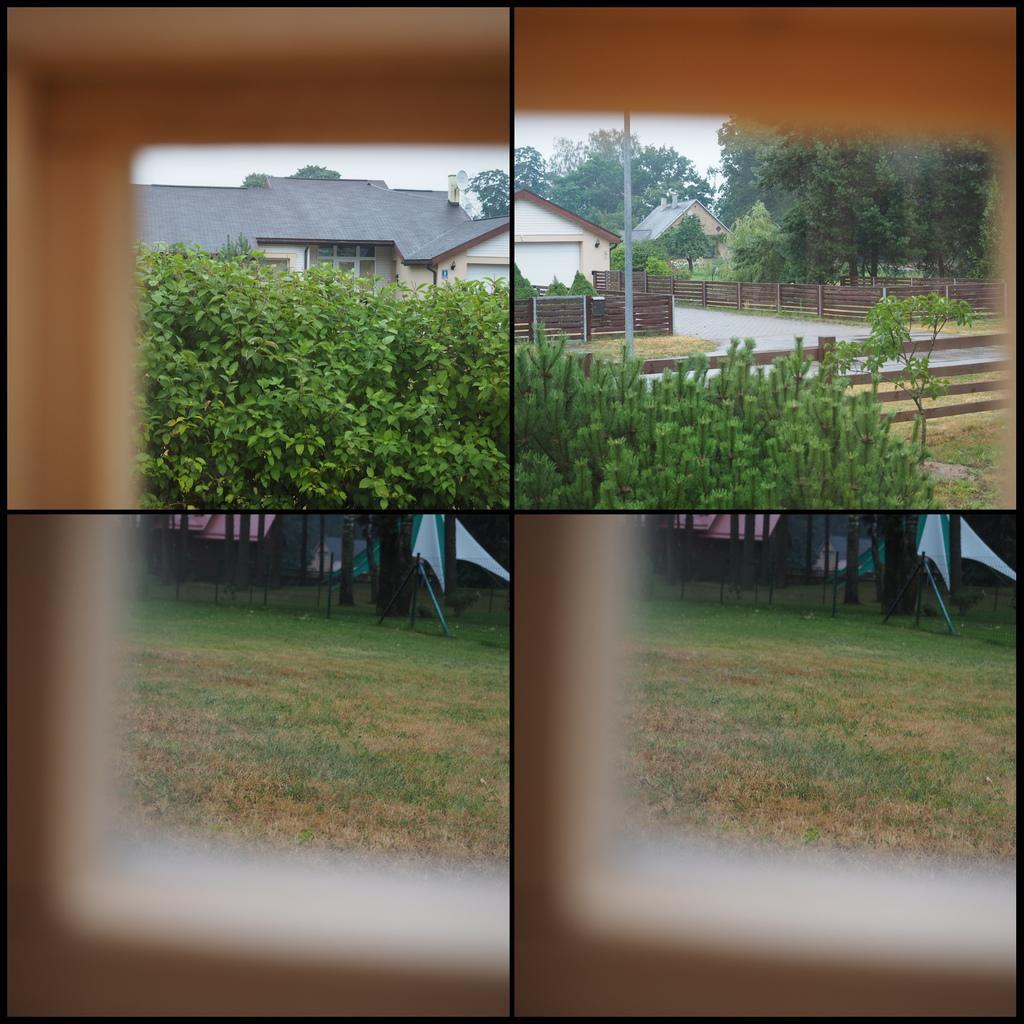Please provide a concise description of this image. This is a collage image, we can see some plants and there is grass on the ground, we can see a house and there is a fence and we can see flags. 